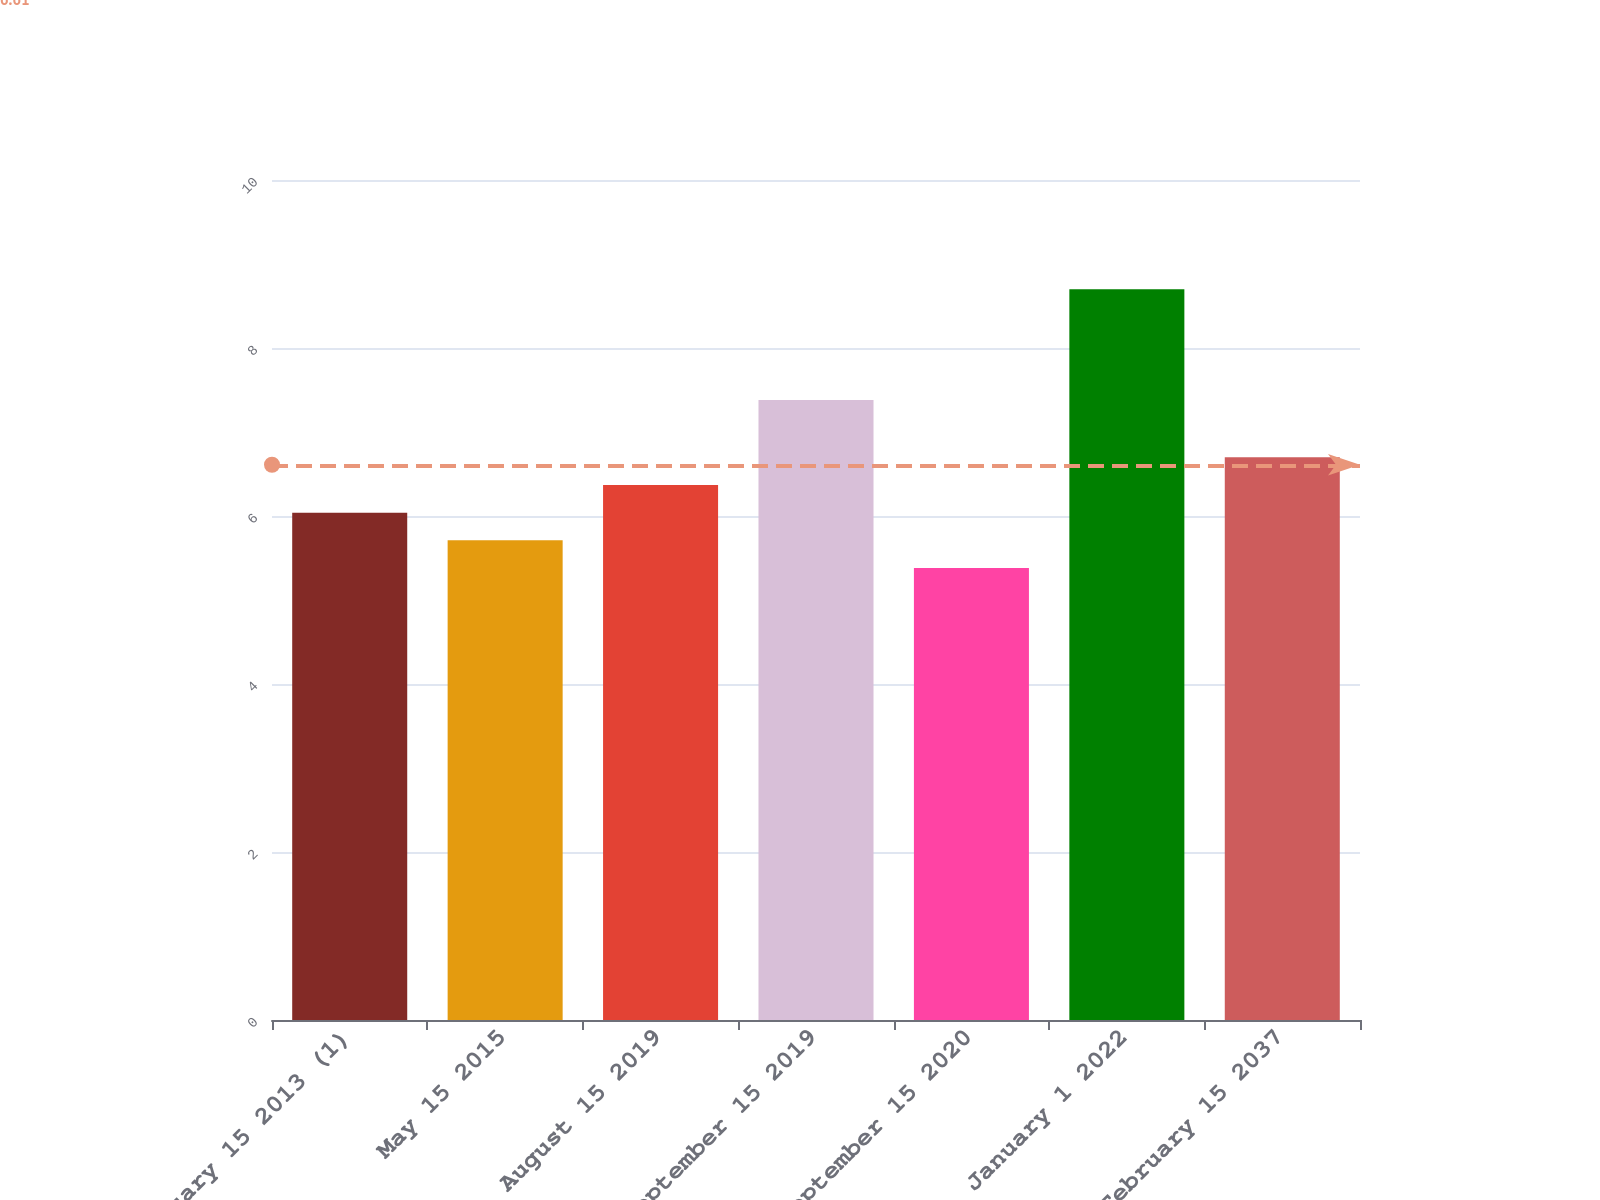Convert chart to OTSL. <chart><loc_0><loc_0><loc_500><loc_500><bar_chart><fcel>February 15 2013 (1)<fcel>May 15 2015<fcel>August 15 2019<fcel>September 15 2019<fcel>September 15 2020<fcel>January 1 2022<fcel>February 15 2037<nl><fcel>6.04<fcel>5.71<fcel>6.37<fcel>7.38<fcel>5.38<fcel>8.7<fcel>6.7<nl></chart> 